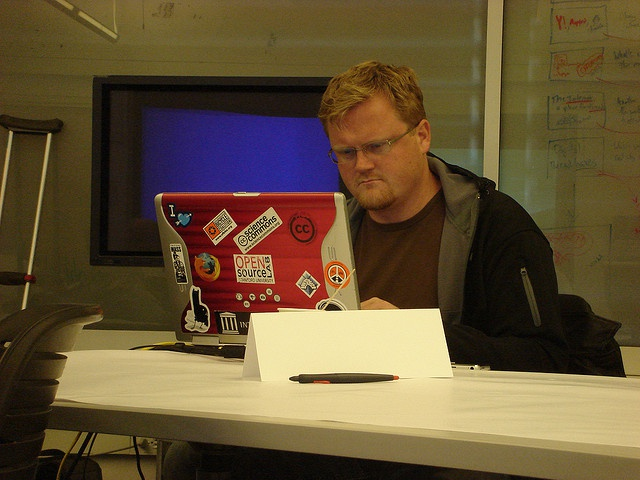Describe the objects in this image and their specific colors. I can see dining table in maroon and tan tones, people in maroon, black, and brown tones, tv in maroon, black, navy, and darkblue tones, laptop in maroon, brown, black, and tan tones, and chair in maroon, black, and olive tones in this image. 